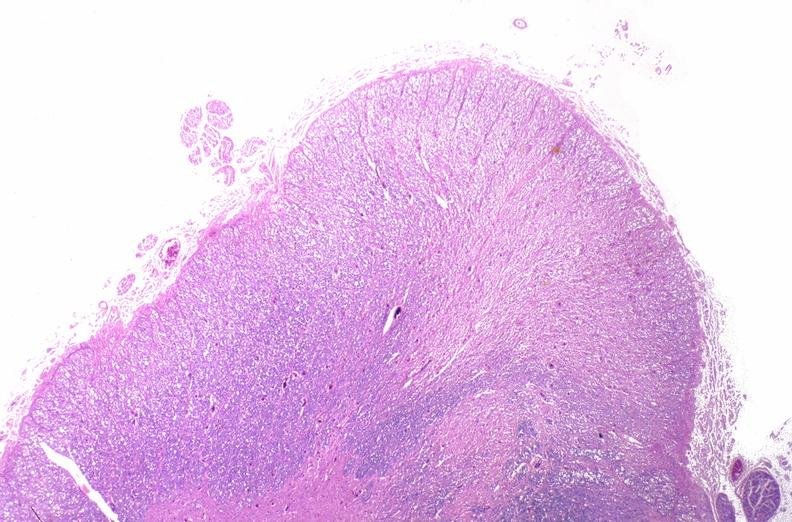what is present?
Answer the question using a single word or phrase. Nervous 